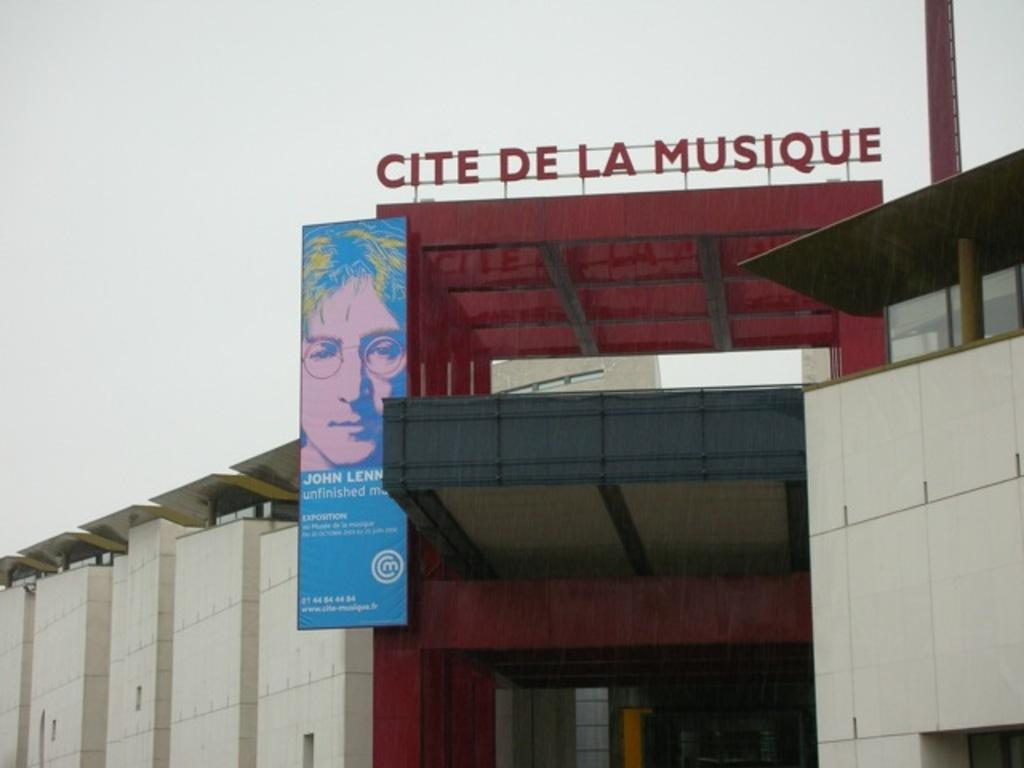What type of structure is in the picture? There is a building in the picture. What is the name of the building? The name of the building is CITE DE LA MUSIQUE. What can be seen behind the building? The sky is visible behind the building. What type of skin is visible on the building in the image? There is no skin visible on the building in the image; it is a structure made of materials like concrete or glass. 